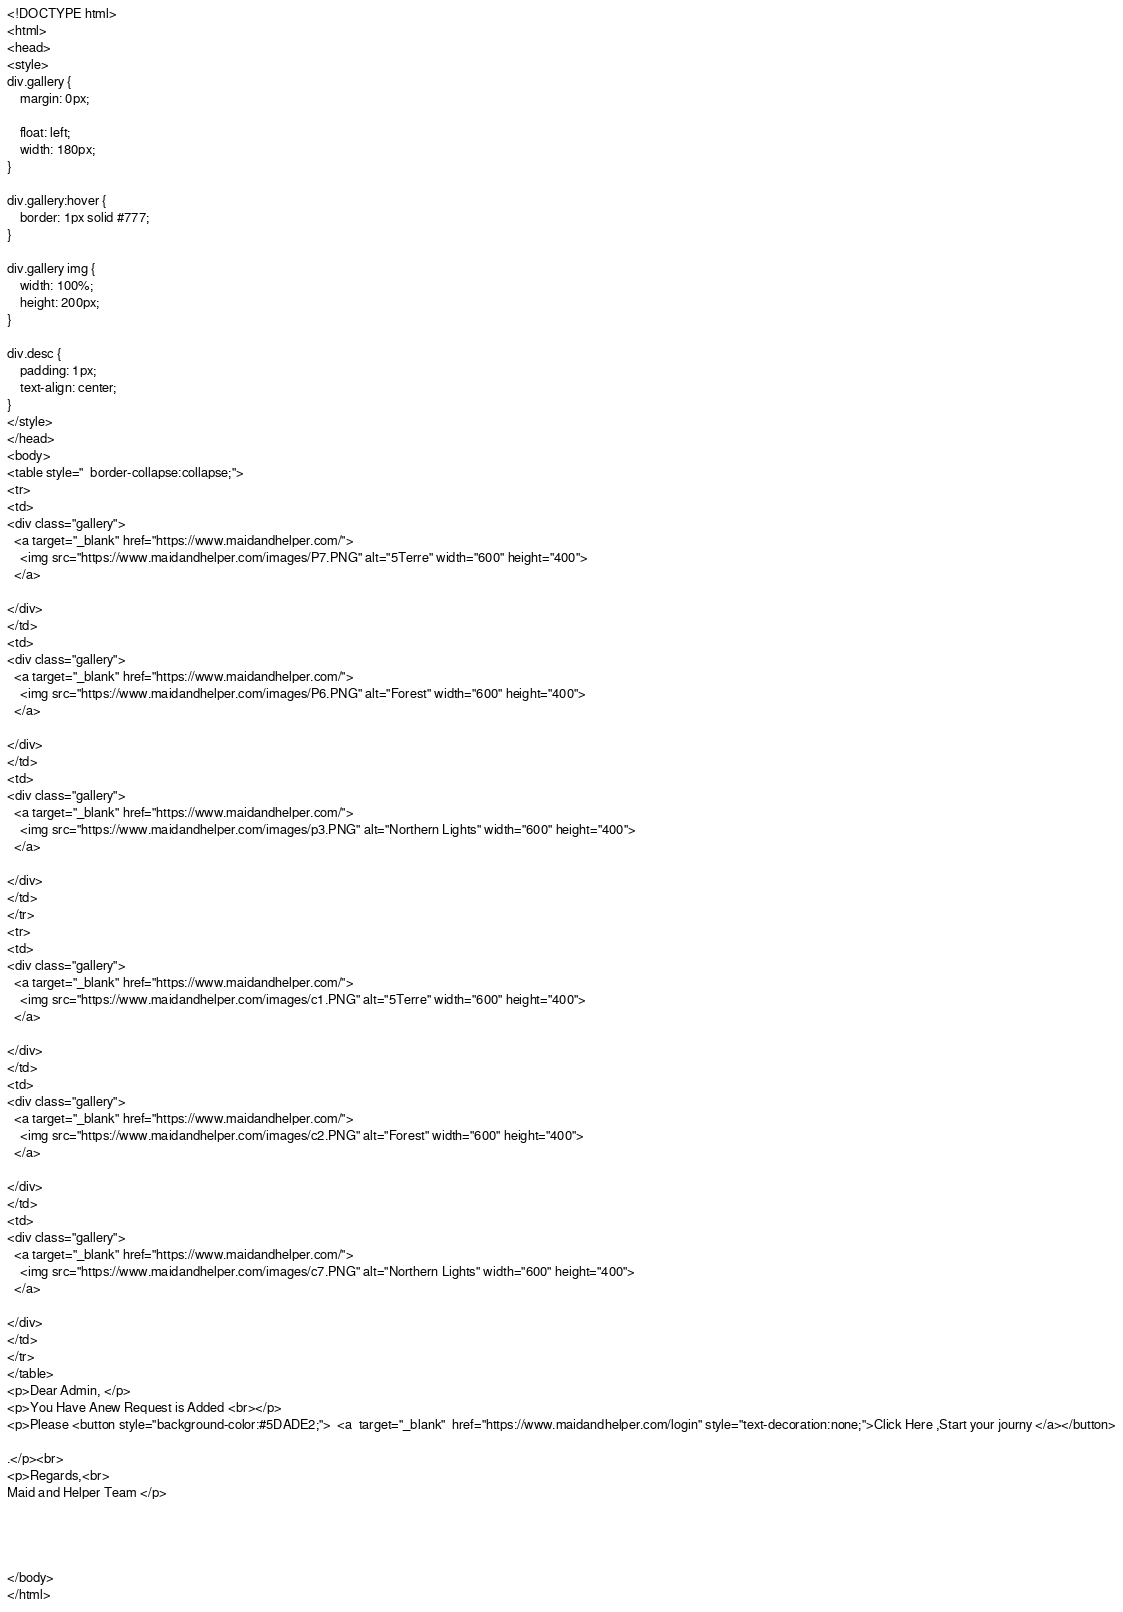<code> <loc_0><loc_0><loc_500><loc_500><_PHP_><!DOCTYPE html>
<html>
<head>
<style>
div.gallery {
    margin: 0px;
  
    float: left;
    width: 180px;
}

div.gallery:hover {
    border: 1px solid #777;
}

div.gallery img {
    width: 100%;
    height: 200px;
}

div.desc {
    padding: 1px;
    text-align: center;
}
</style>
</head>
<body>
<table style="  border-collapse:collapse;">
<tr>
<td>
<div class="gallery">
  <a target="_blank" href="https://www.maidandhelper.com/">
    <img src="https://www.maidandhelper.com/images/P7.PNG" alt="5Terre" width="600" height="400">
  </a>
 
</div>
</td>
<td>
<div class="gallery">
  <a target="_blank" href="https://www.maidandhelper.com/">
    <img src="https://www.maidandhelper.com/images/P6.PNG" alt="Forest" width="600" height="400">
  </a>
  
</div>
</td>
<td>
<div class="gallery">
  <a target="_blank" href="https://www.maidandhelper.com/">
    <img src="https://www.maidandhelper.com/images/p3.PNG" alt="Northern Lights" width="600" height="400">
  </a>
 
</div>
</td>
</tr>
<tr>
<td>
<div class="gallery">
  <a target="_blank" href="https://www.maidandhelper.com/">
    <img src="https://www.maidandhelper.com/images/c1.PNG" alt="5Terre" width="600" height="400">
  </a>
 
</div>
</td>
<td>
<div class="gallery">
  <a target="_blank" href="https://www.maidandhelper.com/">
    <img src="https://www.maidandhelper.com/images/c2.PNG" alt="Forest" width="600" height="400">
  </a>
  
</div>
</td>
<td>
<div class="gallery">
  <a target="_blank" href="https://www.maidandhelper.com/">
    <img src="https://www.maidandhelper.com/images/c7.PNG" alt="Northern Lights" width="600" height="400">
  </a>
 
</div>
</td>
</tr>
</table>
<p>Dear Admin, </p>
<p>You Have Anew Request is Added <br></p>
<p>Please <button style="background-color:#5DADE2;">  <a  target="_blank"  href="https://www.maidandhelper.com/login" style="text-decoration:none;">Click Here ,Start your journy </a></button>

.</p><br>
<p>Regards,<br>
Maid and Helper Team </p>




</body>
</html>
</code> 